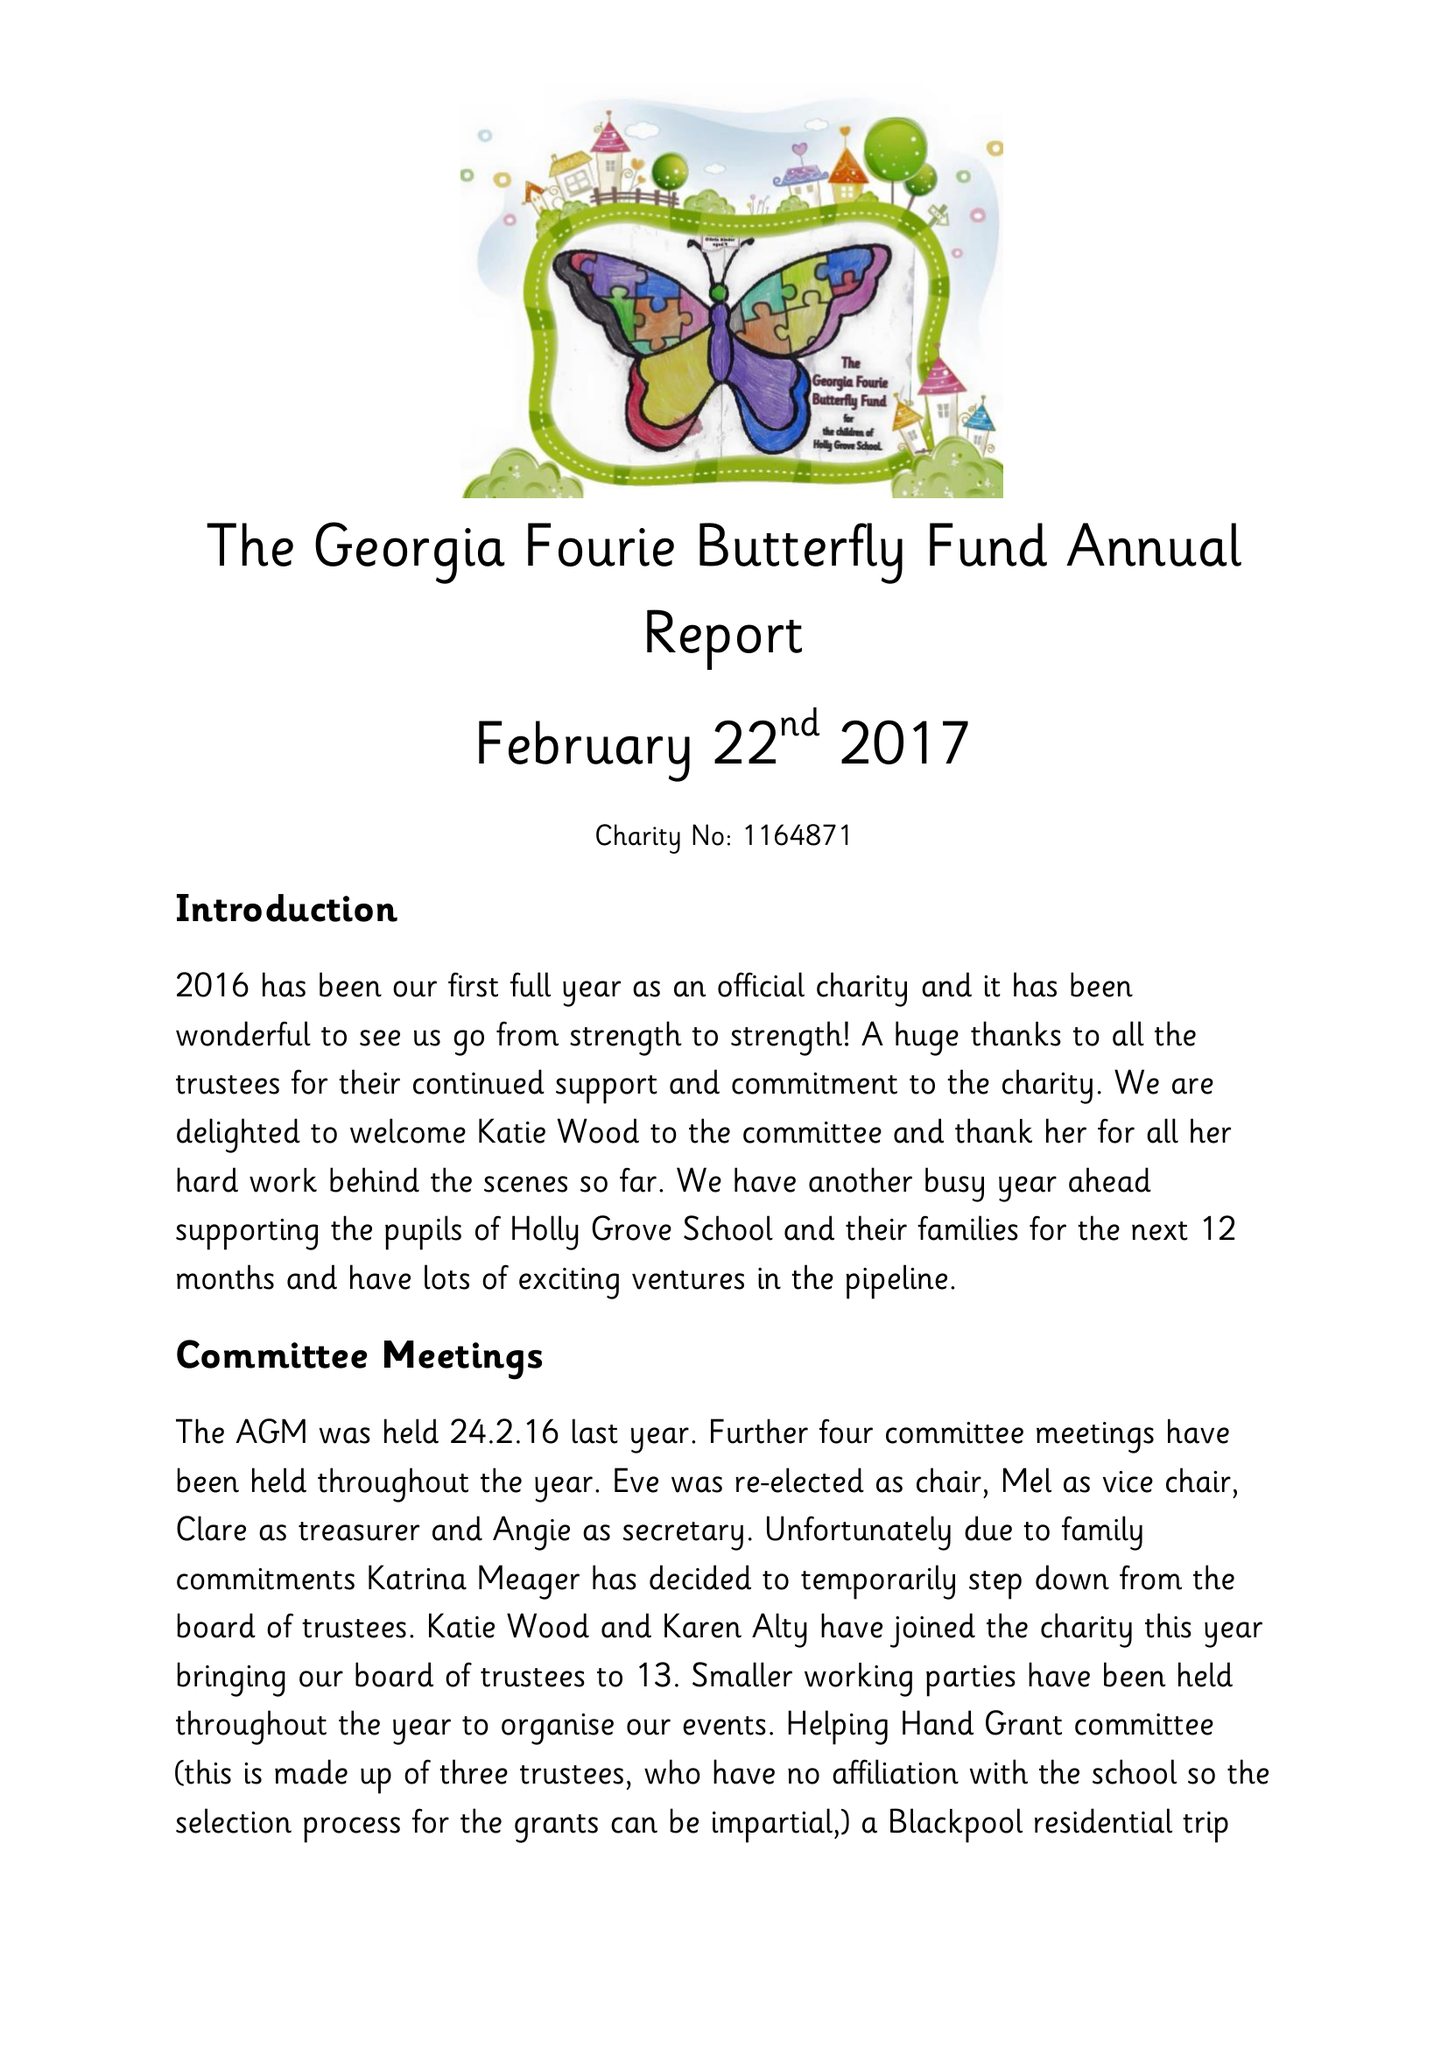What is the value for the charity_number?
Answer the question using a single word or phrase. 1164871 